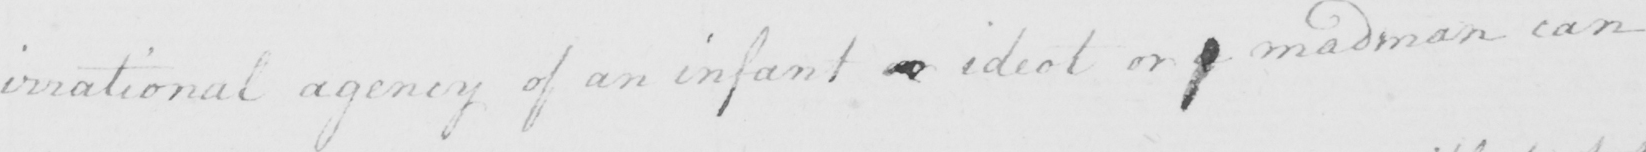Please transcribe the handwritten text in this image. irrational agency of an infant or ideot or a madman can 